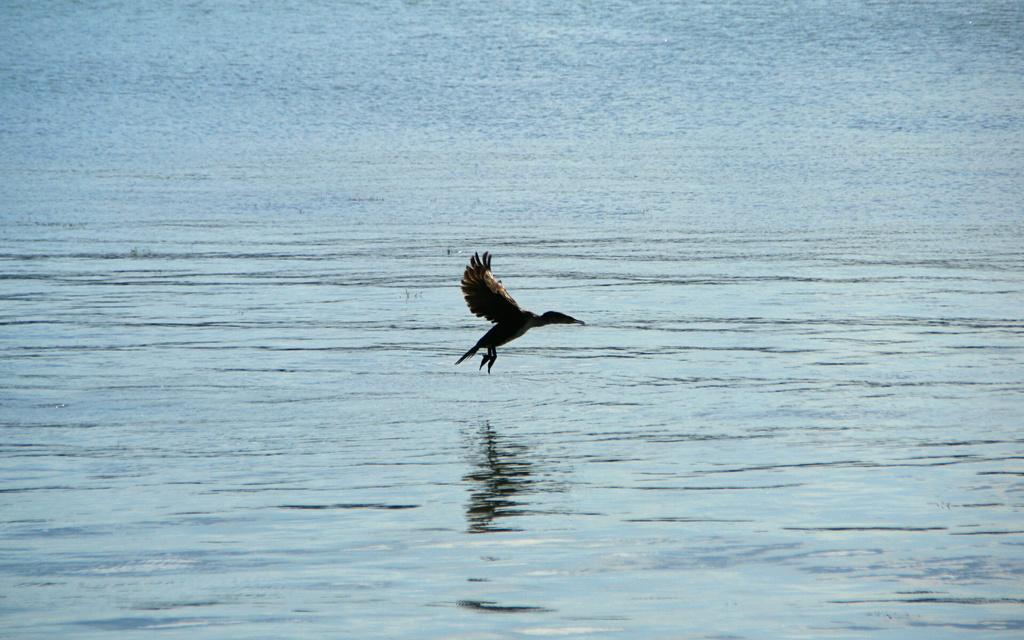What type of animal can be seen in the image? There is a bird in the image. What is the bird doing in the image? The bird is flying. What can be seen in the background of the image? There are waves visible in the image. What is the primary substance visible in the image? Water is visible in the image. How does the bird apply the brake while flying in the image? Birds do not have brakes; they control their flight by adjusting their wings and body position. --- 